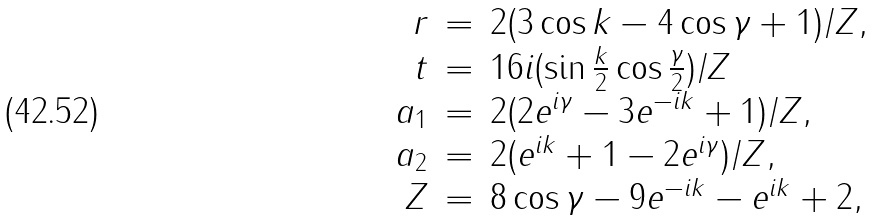<formula> <loc_0><loc_0><loc_500><loc_500>\begin{array} { r c l } r & = & 2 ( 3 \cos { k } - 4 \cos { \gamma } + 1 ) / Z , \\ t & = & 1 6 i ( \sin { \frac { k } { 2 } } \cos { \frac { \gamma } { 2 } } ) / Z \\ a _ { 1 } & = & 2 ( 2 e ^ { i \gamma } - 3 e ^ { - i k } + 1 ) / Z , \\ a _ { 2 } & = & 2 ( e ^ { i k } + 1 - 2 e ^ { i \gamma } ) / Z , \\ Z & = & 8 \cos { \gamma } - 9 e ^ { - i k } - e ^ { i k } + 2 , \\ \end{array}</formula> 